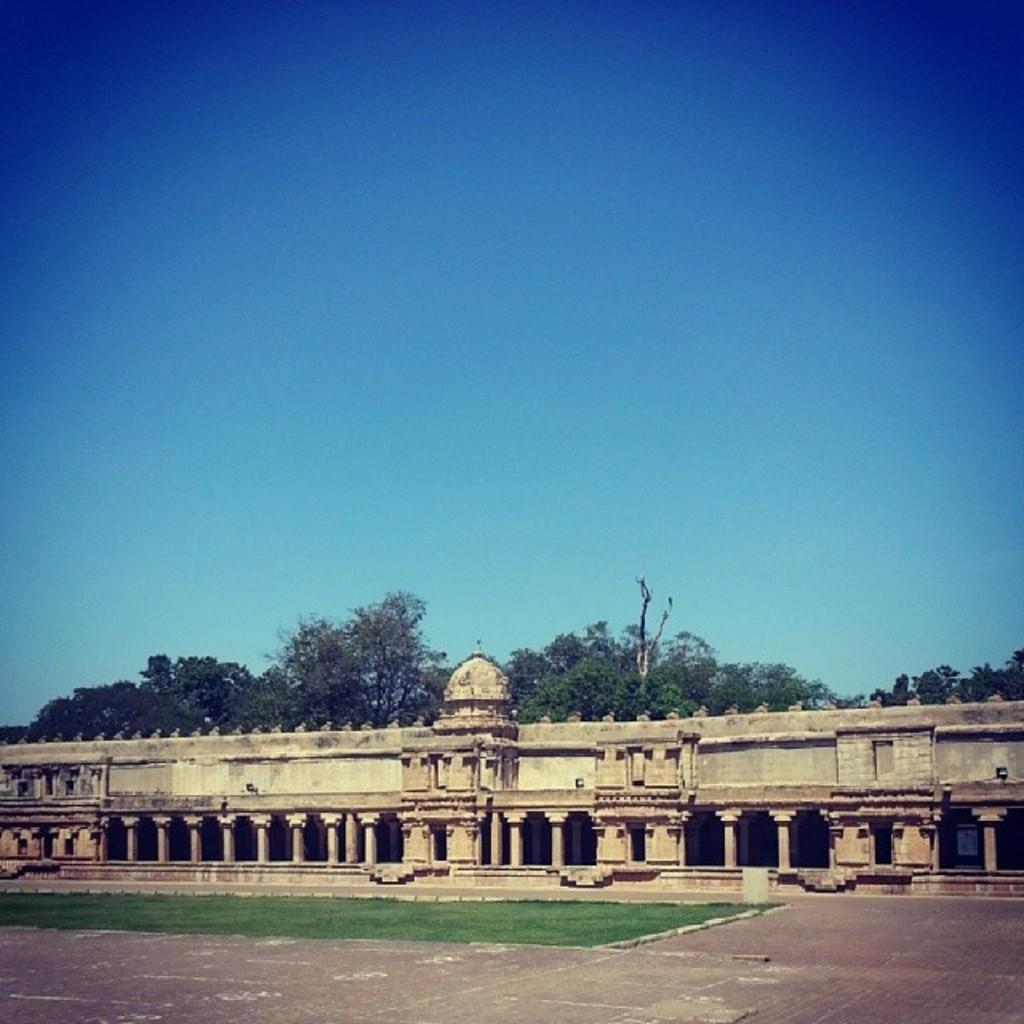What type of surface can be seen in the image? There is ground visible in the image. What type of vegetation is present in the image? There is grass in the image. What type of structure is in the image? There is a building in the image. What can be seen in the background of the image? There are trees and the sky visible in the background of the image. Where is the mailbox located in the image? There is no mailbox present in the image. What type of jelly can be seen on the grass in the image? There is no jelly present on the grass in the image. 